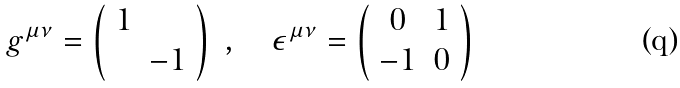Convert formula to latex. <formula><loc_0><loc_0><loc_500><loc_500>g ^ { \mu \nu } = \left ( \begin{array} { c c } 1 & \\ & - 1 \end{array} \right ) \ , \quad \epsilon ^ { \mu \nu } = \left ( \begin{array} { c c } 0 & 1 \\ - 1 & 0 \end{array} \right )</formula> 